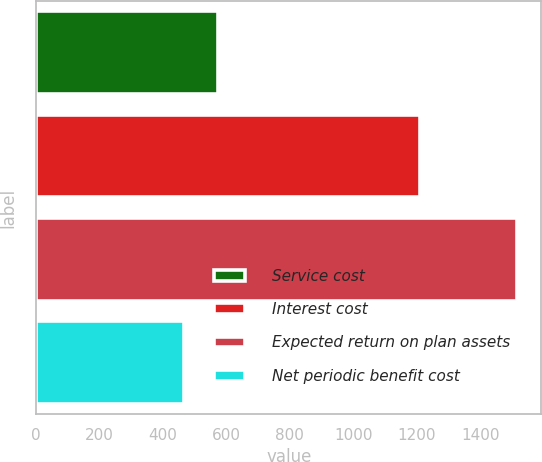Convert chart to OTSL. <chart><loc_0><loc_0><loc_500><loc_500><bar_chart><fcel>Service cost<fcel>Interest cost<fcel>Expected return on plan assets<fcel>Net periodic benefit cost<nl><fcel>572<fcel>1212<fcel>1517<fcel>467<nl></chart> 